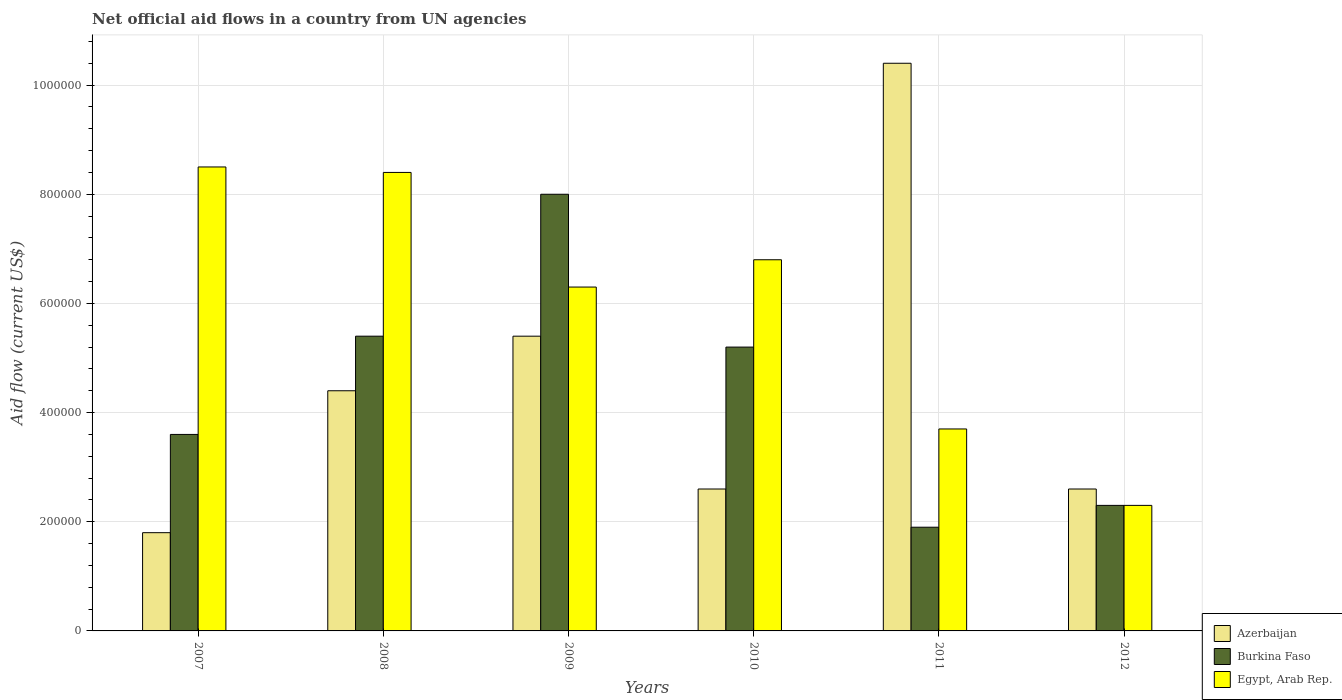How many different coloured bars are there?
Make the answer very short. 3. What is the net official aid flow in Burkina Faso in 2008?
Offer a very short reply. 5.40e+05. Across all years, what is the maximum net official aid flow in Egypt, Arab Rep.?
Offer a terse response. 8.50e+05. Across all years, what is the minimum net official aid flow in Azerbaijan?
Your answer should be compact. 1.80e+05. What is the total net official aid flow in Burkina Faso in the graph?
Offer a terse response. 2.64e+06. What is the difference between the net official aid flow in Burkina Faso in 2007 and that in 2009?
Give a very brief answer. -4.40e+05. What is the difference between the net official aid flow in Egypt, Arab Rep. in 2010 and the net official aid flow in Burkina Faso in 2012?
Make the answer very short. 4.50e+05. In the year 2012, what is the difference between the net official aid flow in Egypt, Arab Rep. and net official aid flow in Azerbaijan?
Make the answer very short. -3.00e+04. In how many years, is the net official aid flow in Egypt, Arab Rep. greater than 240000 US$?
Provide a short and direct response. 5. What is the ratio of the net official aid flow in Burkina Faso in 2010 to that in 2011?
Offer a terse response. 2.74. What is the difference between the highest and the lowest net official aid flow in Egypt, Arab Rep.?
Offer a terse response. 6.20e+05. What does the 2nd bar from the left in 2007 represents?
Your answer should be compact. Burkina Faso. What does the 2nd bar from the right in 2008 represents?
Give a very brief answer. Burkina Faso. Is it the case that in every year, the sum of the net official aid flow in Burkina Faso and net official aid flow in Azerbaijan is greater than the net official aid flow in Egypt, Arab Rep.?
Make the answer very short. No. Does the graph contain any zero values?
Ensure brevity in your answer.  No. Where does the legend appear in the graph?
Make the answer very short. Bottom right. How are the legend labels stacked?
Your answer should be compact. Vertical. What is the title of the graph?
Offer a terse response. Net official aid flows in a country from UN agencies. Does "Solomon Islands" appear as one of the legend labels in the graph?
Provide a short and direct response. No. What is the label or title of the X-axis?
Make the answer very short. Years. What is the Aid flow (current US$) in Egypt, Arab Rep. in 2007?
Offer a terse response. 8.50e+05. What is the Aid flow (current US$) in Azerbaijan in 2008?
Your response must be concise. 4.40e+05. What is the Aid flow (current US$) in Burkina Faso in 2008?
Make the answer very short. 5.40e+05. What is the Aid flow (current US$) in Egypt, Arab Rep. in 2008?
Your response must be concise. 8.40e+05. What is the Aid flow (current US$) of Azerbaijan in 2009?
Make the answer very short. 5.40e+05. What is the Aid flow (current US$) of Burkina Faso in 2009?
Your response must be concise. 8.00e+05. What is the Aid flow (current US$) of Egypt, Arab Rep. in 2009?
Offer a very short reply. 6.30e+05. What is the Aid flow (current US$) of Burkina Faso in 2010?
Make the answer very short. 5.20e+05. What is the Aid flow (current US$) in Egypt, Arab Rep. in 2010?
Provide a succinct answer. 6.80e+05. What is the Aid flow (current US$) in Azerbaijan in 2011?
Your answer should be compact. 1.04e+06. What is the Aid flow (current US$) in Egypt, Arab Rep. in 2011?
Make the answer very short. 3.70e+05. Across all years, what is the maximum Aid flow (current US$) in Azerbaijan?
Your answer should be very brief. 1.04e+06. Across all years, what is the maximum Aid flow (current US$) of Burkina Faso?
Your answer should be very brief. 8.00e+05. Across all years, what is the maximum Aid flow (current US$) in Egypt, Arab Rep.?
Make the answer very short. 8.50e+05. Across all years, what is the minimum Aid flow (current US$) of Azerbaijan?
Make the answer very short. 1.80e+05. What is the total Aid flow (current US$) of Azerbaijan in the graph?
Provide a succinct answer. 2.72e+06. What is the total Aid flow (current US$) in Burkina Faso in the graph?
Provide a succinct answer. 2.64e+06. What is the total Aid flow (current US$) of Egypt, Arab Rep. in the graph?
Keep it short and to the point. 3.60e+06. What is the difference between the Aid flow (current US$) in Azerbaijan in 2007 and that in 2009?
Give a very brief answer. -3.60e+05. What is the difference between the Aid flow (current US$) of Burkina Faso in 2007 and that in 2009?
Provide a short and direct response. -4.40e+05. What is the difference between the Aid flow (current US$) of Azerbaijan in 2007 and that in 2010?
Provide a succinct answer. -8.00e+04. What is the difference between the Aid flow (current US$) of Egypt, Arab Rep. in 2007 and that in 2010?
Give a very brief answer. 1.70e+05. What is the difference between the Aid flow (current US$) in Azerbaijan in 2007 and that in 2011?
Your response must be concise. -8.60e+05. What is the difference between the Aid flow (current US$) of Burkina Faso in 2007 and that in 2011?
Give a very brief answer. 1.70e+05. What is the difference between the Aid flow (current US$) of Burkina Faso in 2007 and that in 2012?
Ensure brevity in your answer.  1.30e+05. What is the difference between the Aid flow (current US$) in Egypt, Arab Rep. in 2007 and that in 2012?
Provide a short and direct response. 6.20e+05. What is the difference between the Aid flow (current US$) in Azerbaijan in 2008 and that in 2009?
Keep it short and to the point. -1.00e+05. What is the difference between the Aid flow (current US$) in Burkina Faso in 2008 and that in 2009?
Keep it short and to the point. -2.60e+05. What is the difference between the Aid flow (current US$) of Burkina Faso in 2008 and that in 2010?
Provide a succinct answer. 2.00e+04. What is the difference between the Aid flow (current US$) in Azerbaijan in 2008 and that in 2011?
Provide a short and direct response. -6.00e+05. What is the difference between the Aid flow (current US$) of Burkina Faso in 2008 and that in 2011?
Your answer should be very brief. 3.50e+05. What is the difference between the Aid flow (current US$) in Egypt, Arab Rep. in 2008 and that in 2011?
Provide a succinct answer. 4.70e+05. What is the difference between the Aid flow (current US$) of Azerbaijan in 2008 and that in 2012?
Keep it short and to the point. 1.80e+05. What is the difference between the Aid flow (current US$) in Azerbaijan in 2009 and that in 2010?
Provide a succinct answer. 2.80e+05. What is the difference between the Aid flow (current US$) of Burkina Faso in 2009 and that in 2010?
Keep it short and to the point. 2.80e+05. What is the difference between the Aid flow (current US$) in Azerbaijan in 2009 and that in 2011?
Offer a very short reply. -5.00e+05. What is the difference between the Aid flow (current US$) of Burkina Faso in 2009 and that in 2012?
Offer a terse response. 5.70e+05. What is the difference between the Aid flow (current US$) in Egypt, Arab Rep. in 2009 and that in 2012?
Your response must be concise. 4.00e+05. What is the difference between the Aid flow (current US$) in Azerbaijan in 2010 and that in 2011?
Make the answer very short. -7.80e+05. What is the difference between the Aid flow (current US$) of Burkina Faso in 2010 and that in 2011?
Your answer should be very brief. 3.30e+05. What is the difference between the Aid flow (current US$) of Burkina Faso in 2010 and that in 2012?
Offer a terse response. 2.90e+05. What is the difference between the Aid flow (current US$) in Egypt, Arab Rep. in 2010 and that in 2012?
Your response must be concise. 4.50e+05. What is the difference between the Aid flow (current US$) of Azerbaijan in 2011 and that in 2012?
Ensure brevity in your answer.  7.80e+05. What is the difference between the Aid flow (current US$) of Egypt, Arab Rep. in 2011 and that in 2012?
Ensure brevity in your answer.  1.40e+05. What is the difference between the Aid flow (current US$) in Azerbaijan in 2007 and the Aid flow (current US$) in Burkina Faso in 2008?
Your answer should be compact. -3.60e+05. What is the difference between the Aid flow (current US$) in Azerbaijan in 2007 and the Aid flow (current US$) in Egypt, Arab Rep. in 2008?
Offer a terse response. -6.60e+05. What is the difference between the Aid flow (current US$) of Burkina Faso in 2007 and the Aid flow (current US$) of Egypt, Arab Rep. in 2008?
Offer a very short reply. -4.80e+05. What is the difference between the Aid flow (current US$) in Azerbaijan in 2007 and the Aid flow (current US$) in Burkina Faso in 2009?
Provide a short and direct response. -6.20e+05. What is the difference between the Aid flow (current US$) of Azerbaijan in 2007 and the Aid flow (current US$) of Egypt, Arab Rep. in 2009?
Your answer should be compact. -4.50e+05. What is the difference between the Aid flow (current US$) in Azerbaijan in 2007 and the Aid flow (current US$) in Egypt, Arab Rep. in 2010?
Provide a succinct answer. -5.00e+05. What is the difference between the Aid flow (current US$) in Burkina Faso in 2007 and the Aid flow (current US$) in Egypt, Arab Rep. in 2010?
Make the answer very short. -3.20e+05. What is the difference between the Aid flow (current US$) in Azerbaijan in 2007 and the Aid flow (current US$) in Egypt, Arab Rep. in 2011?
Provide a short and direct response. -1.90e+05. What is the difference between the Aid flow (current US$) in Azerbaijan in 2007 and the Aid flow (current US$) in Burkina Faso in 2012?
Your response must be concise. -5.00e+04. What is the difference between the Aid flow (current US$) in Azerbaijan in 2008 and the Aid flow (current US$) in Burkina Faso in 2009?
Provide a succinct answer. -3.60e+05. What is the difference between the Aid flow (current US$) in Burkina Faso in 2008 and the Aid flow (current US$) in Egypt, Arab Rep. in 2009?
Make the answer very short. -9.00e+04. What is the difference between the Aid flow (current US$) in Azerbaijan in 2008 and the Aid flow (current US$) in Burkina Faso in 2010?
Ensure brevity in your answer.  -8.00e+04. What is the difference between the Aid flow (current US$) in Azerbaijan in 2008 and the Aid flow (current US$) in Egypt, Arab Rep. in 2010?
Offer a terse response. -2.40e+05. What is the difference between the Aid flow (current US$) in Azerbaijan in 2008 and the Aid flow (current US$) in Burkina Faso in 2011?
Your answer should be very brief. 2.50e+05. What is the difference between the Aid flow (current US$) of Azerbaijan in 2008 and the Aid flow (current US$) of Egypt, Arab Rep. in 2011?
Provide a succinct answer. 7.00e+04. What is the difference between the Aid flow (current US$) of Burkina Faso in 2008 and the Aid flow (current US$) of Egypt, Arab Rep. in 2011?
Provide a succinct answer. 1.70e+05. What is the difference between the Aid flow (current US$) of Burkina Faso in 2008 and the Aid flow (current US$) of Egypt, Arab Rep. in 2012?
Your answer should be compact. 3.10e+05. What is the difference between the Aid flow (current US$) in Azerbaijan in 2009 and the Aid flow (current US$) in Burkina Faso in 2010?
Offer a very short reply. 2.00e+04. What is the difference between the Aid flow (current US$) in Burkina Faso in 2009 and the Aid flow (current US$) in Egypt, Arab Rep. in 2010?
Offer a terse response. 1.20e+05. What is the difference between the Aid flow (current US$) of Azerbaijan in 2009 and the Aid flow (current US$) of Burkina Faso in 2011?
Provide a short and direct response. 3.50e+05. What is the difference between the Aid flow (current US$) of Burkina Faso in 2009 and the Aid flow (current US$) of Egypt, Arab Rep. in 2011?
Your answer should be very brief. 4.30e+05. What is the difference between the Aid flow (current US$) of Burkina Faso in 2009 and the Aid flow (current US$) of Egypt, Arab Rep. in 2012?
Keep it short and to the point. 5.70e+05. What is the difference between the Aid flow (current US$) in Azerbaijan in 2010 and the Aid flow (current US$) in Burkina Faso in 2011?
Provide a short and direct response. 7.00e+04. What is the difference between the Aid flow (current US$) in Azerbaijan in 2010 and the Aid flow (current US$) in Egypt, Arab Rep. in 2011?
Give a very brief answer. -1.10e+05. What is the difference between the Aid flow (current US$) in Azerbaijan in 2010 and the Aid flow (current US$) in Burkina Faso in 2012?
Keep it short and to the point. 3.00e+04. What is the difference between the Aid flow (current US$) in Burkina Faso in 2010 and the Aid flow (current US$) in Egypt, Arab Rep. in 2012?
Ensure brevity in your answer.  2.90e+05. What is the difference between the Aid flow (current US$) of Azerbaijan in 2011 and the Aid flow (current US$) of Burkina Faso in 2012?
Offer a very short reply. 8.10e+05. What is the difference between the Aid flow (current US$) of Azerbaijan in 2011 and the Aid flow (current US$) of Egypt, Arab Rep. in 2012?
Offer a very short reply. 8.10e+05. What is the difference between the Aid flow (current US$) in Burkina Faso in 2011 and the Aid flow (current US$) in Egypt, Arab Rep. in 2012?
Offer a very short reply. -4.00e+04. What is the average Aid flow (current US$) in Azerbaijan per year?
Provide a short and direct response. 4.53e+05. In the year 2007, what is the difference between the Aid flow (current US$) in Azerbaijan and Aid flow (current US$) in Burkina Faso?
Provide a succinct answer. -1.80e+05. In the year 2007, what is the difference between the Aid flow (current US$) of Azerbaijan and Aid flow (current US$) of Egypt, Arab Rep.?
Provide a short and direct response. -6.70e+05. In the year 2007, what is the difference between the Aid flow (current US$) in Burkina Faso and Aid flow (current US$) in Egypt, Arab Rep.?
Provide a short and direct response. -4.90e+05. In the year 2008, what is the difference between the Aid flow (current US$) of Azerbaijan and Aid flow (current US$) of Egypt, Arab Rep.?
Your response must be concise. -4.00e+05. In the year 2009, what is the difference between the Aid flow (current US$) of Azerbaijan and Aid flow (current US$) of Egypt, Arab Rep.?
Provide a succinct answer. -9.00e+04. In the year 2010, what is the difference between the Aid flow (current US$) of Azerbaijan and Aid flow (current US$) of Egypt, Arab Rep.?
Keep it short and to the point. -4.20e+05. In the year 2010, what is the difference between the Aid flow (current US$) of Burkina Faso and Aid flow (current US$) of Egypt, Arab Rep.?
Give a very brief answer. -1.60e+05. In the year 2011, what is the difference between the Aid flow (current US$) of Azerbaijan and Aid flow (current US$) of Burkina Faso?
Your answer should be very brief. 8.50e+05. In the year 2011, what is the difference between the Aid flow (current US$) of Azerbaijan and Aid flow (current US$) of Egypt, Arab Rep.?
Offer a terse response. 6.70e+05. In the year 2012, what is the difference between the Aid flow (current US$) in Azerbaijan and Aid flow (current US$) in Burkina Faso?
Your answer should be very brief. 3.00e+04. What is the ratio of the Aid flow (current US$) in Azerbaijan in 2007 to that in 2008?
Keep it short and to the point. 0.41. What is the ratio of the Aid flow (current US$) of Egypt, Arab Rep. in 2007 to that in 2008?
Keep it short and to the point. 1.01. What is the ratio of the Aid flow (current US$) of Burkina Faso in 2007 to that in 2009?
Provide a succinct answer. 0.45. What is the ratio of the Aid flow (current US$) of Egypt, Arab Rep. in 2007 to that in 2009?
Your response must be concise. 1.35. What is the ratio of the Aid flow (current US$) of Azerbaijan in 2007 to that in 2010?
Your answer should be very brief. 0.69. What is the ratio of the Aid flow (current US$) in Burkina Faso in 2007 to that in 2010?
Your answer should be very brief. 0.69. What is the ratio of the Aid flow (current US$) in Azerbaijan in 2007 to that in 2011?
Keep it short and to the point. 0.17. What is the ratio of the Aid flow (current US$) in Burkina Faso in 2007 to that in 2011?
Your answer should be compact. 1.89. What is the ratio of the Aid flow (current US$) of Egypt, Arab Rep. in 2007 to that in 2011?
Offer a terse response. 2.3. What is the ratio of the Aid flow (current US$) in Azerbaijan in 2007 to that in 2012?
Provide a succinct answer. 0.69. What is the ratio of the Aid flow (current US$) of Burkina Faso in 2007 to that in 2012?
Offer a terse response. 1.57. What is the ratio of the Aid flow (current US$) of Egypt, Arab Rep. in 2007 to that in 2012?
Your response must be concise. 3.7. What is the ratio of the Aid flow (current US$) of Azerbaijan in 2008 to that in 2009?
Offer a terse response. 0.81. What is the ratio of the Aid flow (current US$) in Burkina Faso in 2008 to that in 2009?
Keep it short and to the point. 0.68. What is the ratio of the Aid flow (current US$) in Azerbaijan in 2008 to that in 2010?
Provide a succinct answer. 1.69. What is the ratio of the Aid flow (current US$) in Egypt, Arab Rep. in 2008 to that in 2010?
Offer a terse response. 1.24. What is the ratio of the Aid flow (current US$) of Azerbaijan in 2008 to that in 2011?
Ensure brevity in your answer.  0.42. What is the ratio of the Aid flow (current US$) of Burkina Faso in 2008 to that in 2011?
Keep it short and to the point. 2.84. What is the ratio of the Aid flow (current US$) in Egypt, Arab Rep. in 2008 to that in 2011?
Ensure brevity in your answer.  2.27. What is the ratio of the Aid flow (current US$) in Azerbaijan in 2008 to that in 2012?
Provide a short and direct response. 1.69. What is the ratio of the Aid flow (current US$) in Burkina Faso in 2008 to that in 2012?
Offer a very short reply. 2.35. What is the ratio of the Aid flow (current US$) in Egypt, Arab Rep. in 2008 to that in 2012?
Provide a short and direct response. 3.65. What is the ratio of the Aid flow (current US$) of Azerbaijan in 2009 to that in 2010?
Your answer should be compact. 2.08. What is the ratio of the Aid flow (current US$) in Burkina Faso in 2009 to that in 2010?
Offer a very short reply. 1.54. What is the ratio of the Aid flow (current US$) in Egypt, Arab Rep. in 2009 to that in 2010?
Offer a very short reply. 0.93. What is the ratio of the Aid flow (current US$) of Azerbaijan in 2009 to that in 2011?
Offer a terse response. 0.52. What is the ratio of the Aid flow (current US$) of Burkina Faso in 2009 to that in 2011?
Provide a short and direct response. 4.21. What is the ratio of the Aid flow (current US$) in Egypt, Arab Rep. in 2009 to that in 2011?
Make the answer very short. 1.7. What is the ratio of the Aid flow (current US$) in Azerbaijan in 2009 to that in 2012?
Offer a very short reply. 2.08. What is the ratio of the Aid flow (current US$) of Burkina Faso in 2009 to that in 2012?
Ensure brevity in your answer.  3.48. What is the ratio of the Aid flow (current US$) in Egypt, Arab Rep. in 2009 to that in 2012?
Make the answer very short. 2.74. What is the ratio of the Aid flow (current US$) of Azerbaijan in 2010 to that in 2011?
Your answer should be compact. 0.25. What is the ratio of the Aid flow (current US$) of Burkina Faso in 2010 to that in 2011?
Your answer should be very brief. 2.74. What is the ratio of the Aid flow (current US$) of Egypt, Arab Rep. in 2010 to that in 2011?
Provide a short and direct response. 1.84. What is the ratio of the Aid flow (current US$) in Azerbaijan in 2010 to that in 2012?
Your answer should be compact. 1. What is the ratio of the Aid flow (current US$) in Burkina Faso in 2010 to that in 2012?
Offer a very short reply. 2.26. What is the ratio of the Aid flow (current US$) of Egypt, Arab Rep. in 2010 to that in 2012?
Offer a very short reply. 2.96. What is the ratio of the Aid flow (current US$) of Burkina Faso in 2011 to that in 2012?
Make the answer very short. 0.83. What is the ratio of the Aid flow (current US$) of Egypt, Arab Rep. in 2011 to that in 2012?
Your answer should be very brief. 1.61. What is the difference between the highest and the lowest Aid flow (current US$) of Azerbaijan?
Make the answer very short. 8.60e+05. What is the difference between the highest and the lowest Aid flow (current US$) of Egypt, Arab Rep.?
Offer a very short reply. 6.20e+05. 